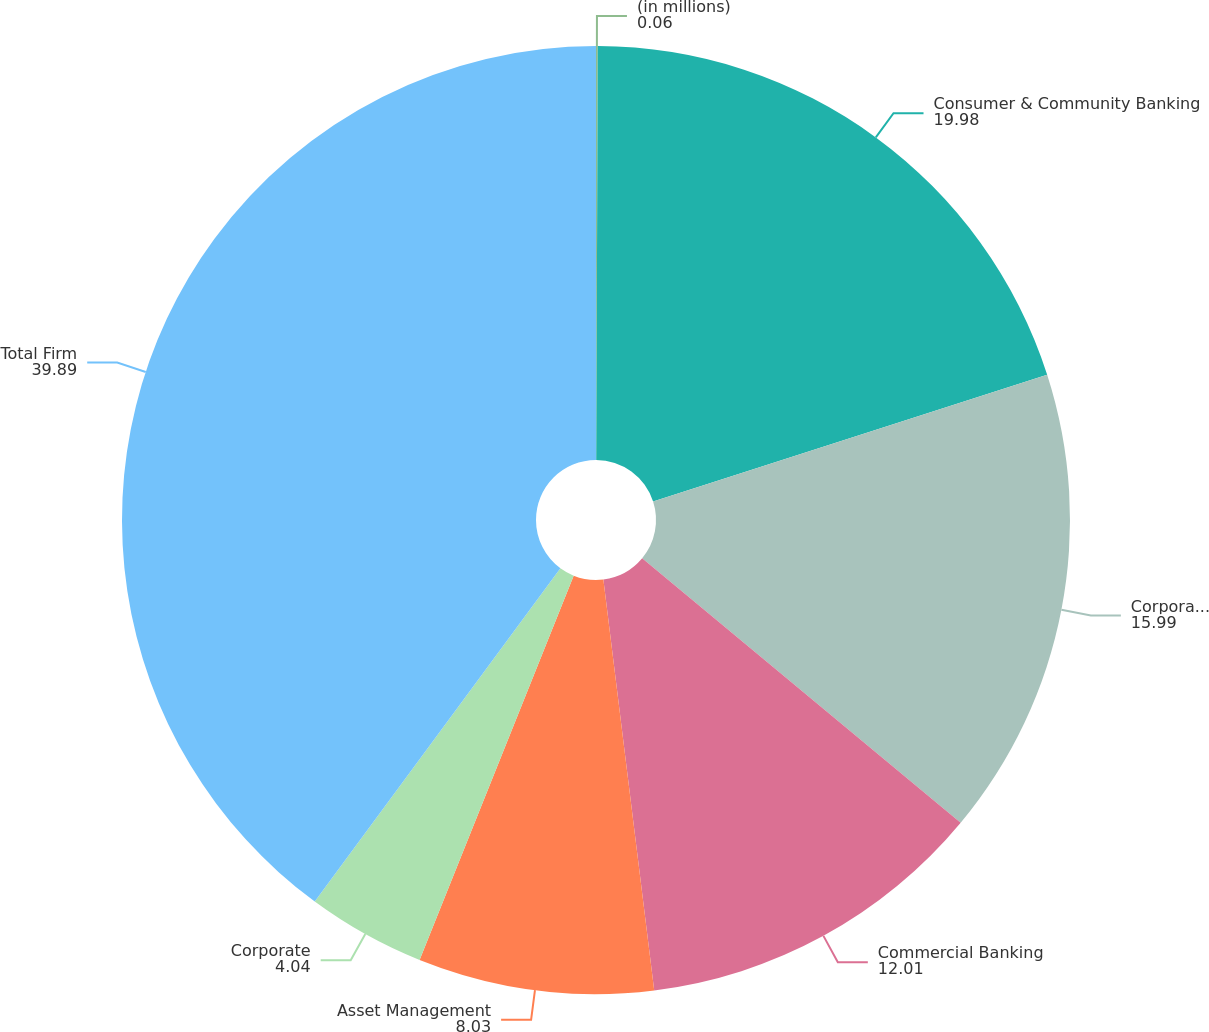Convert chart. <chart><loc_0><loc_0><loc_500><loc_500><pie_chart><fcel>(in millions)<fcel>Consumer & Community Banking<fcel>Corporate & Investment Bank<fcel>Commercial Banking<fcel>Asset Management<fcel>Corporate<fcel>Total Firm<nl><fcel>0.06%<fcel>19.98%<fcel>15.99%<fcel>12.01%<fcel>8.03%<fcel>4.04%<fcel>39.89%<nl></chart> 